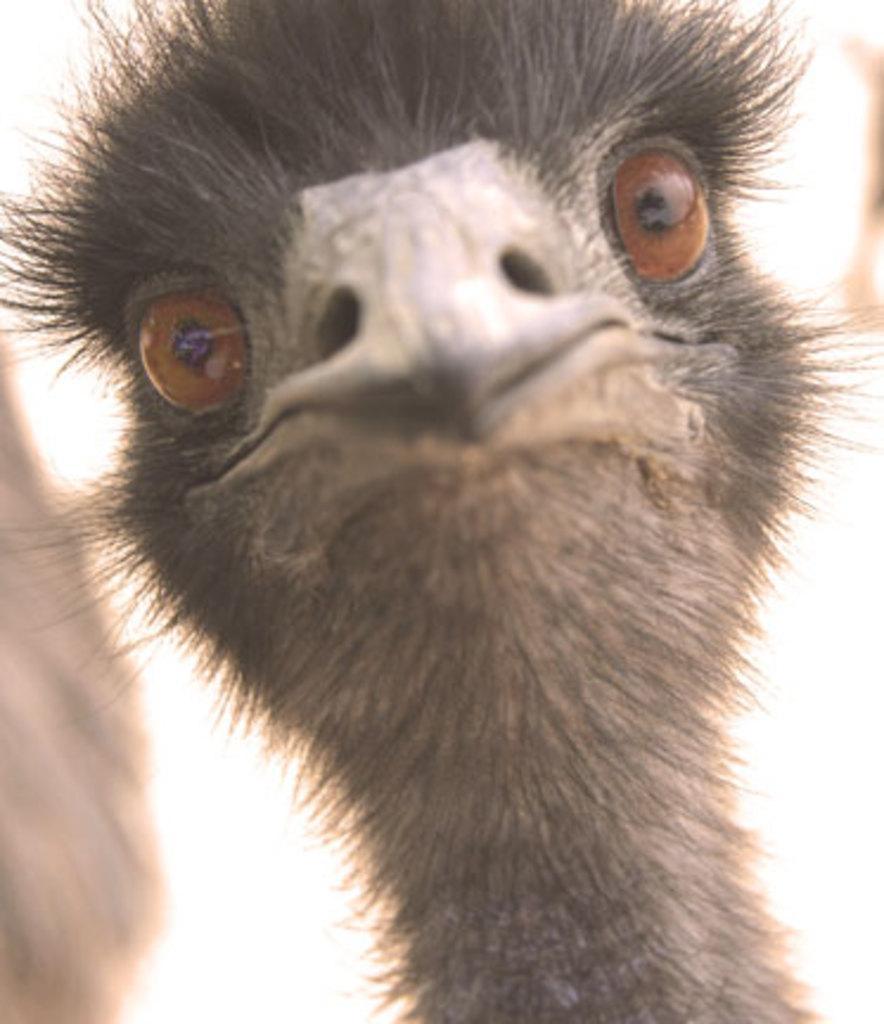Describe this image in one or two sentences. In this image there is a bird with a very sharp beak and round eyes. 